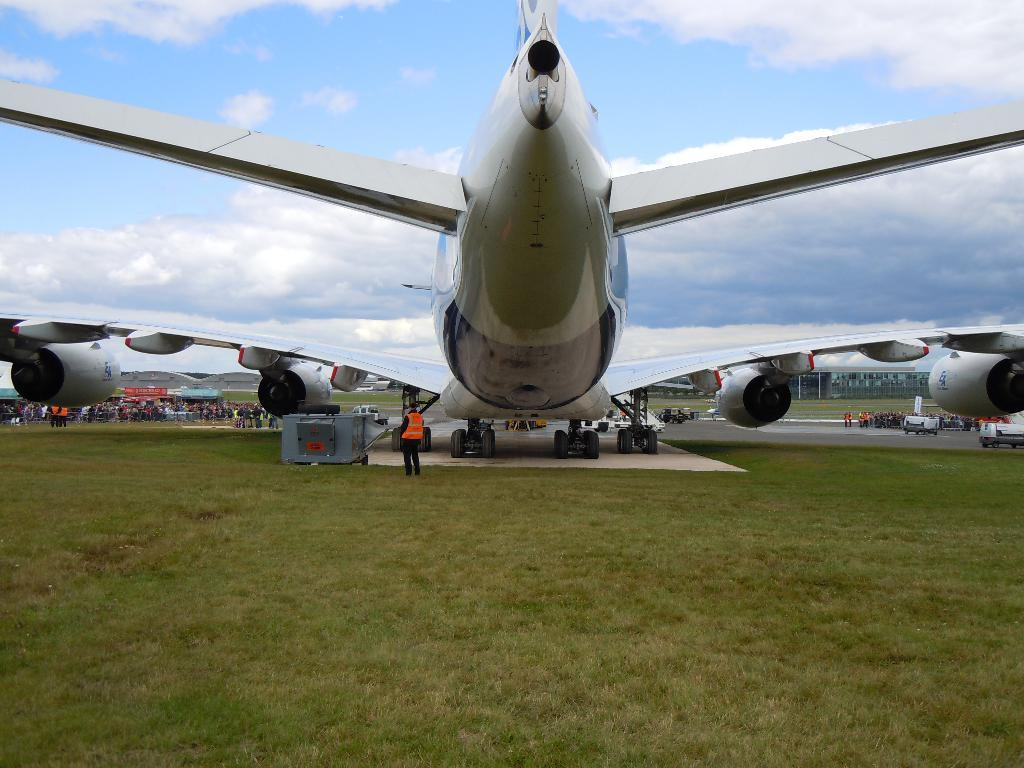What is the main subject of the image? The main subject of the image is an aircraft. What can be seen behind the aircraft? There are vehicles and persons behind the aircraft. What type of terrain is visible at the bottom of the image? There is grass visible at the bottom of the image. What is visible at the top of the image? The sky is visible at the top of the image. How many cacti are present in the image? There are no cacti present in the image. What type of bike can be seen being ridden by the person behind the aircraft? There is no bike visible in the image; only vehicles and persons are present. 